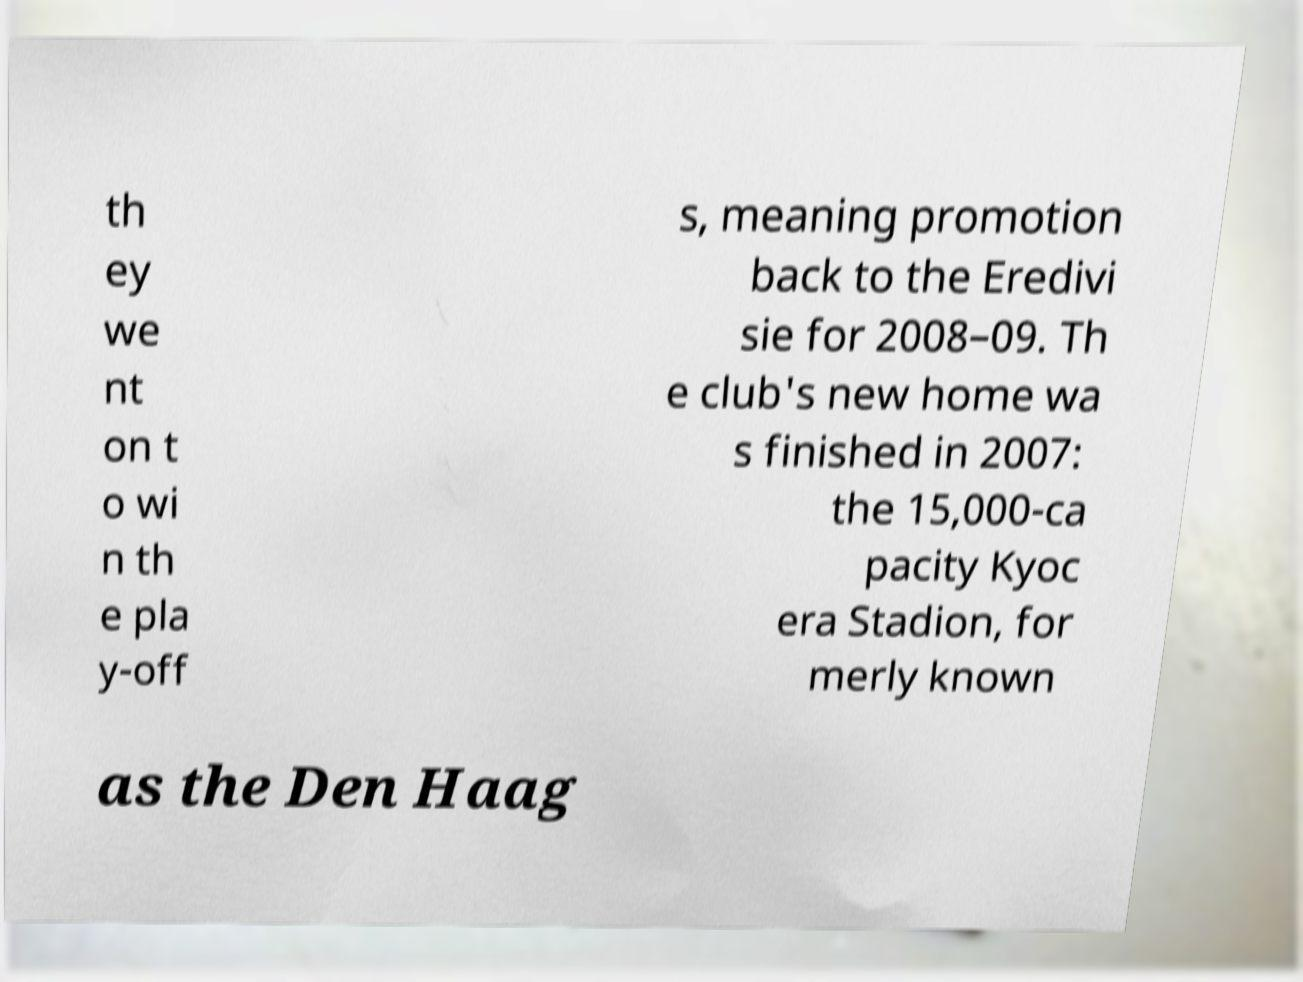There's text embedded in this image that I need extracted. Can you transcribe it verbatim? th ey we nt on t o wi n th e pla y-off s, meaning promotion back to the Eredivi sie for 2008–09. Th e club's new home wa s finished in 2007: the 15,000-ca pacity Kyoc era Stadion, for merly known as the Den Haag 